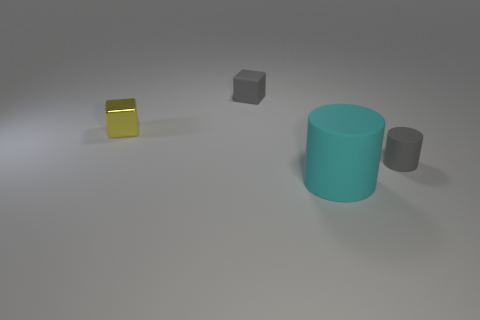Add 1 cylinders. How many objects exist? 5 Subtract all large cyan objects. Subtract all purple objects. How many objects are left? 3 Add 3 gray cubes. How many gray cubes are left? 4 Add 1 small yellow shiny cubes. How many small yellow shiny cubes exist? 2 Subtract 0 cyan balls. How many objects are left? 4 